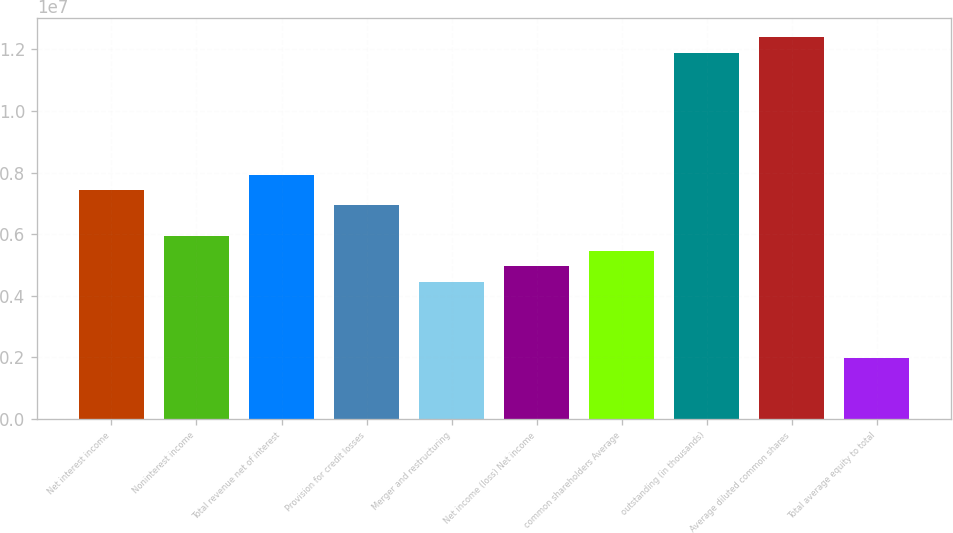Convert chart to OTSL. <chart><loc_0><loc_0><loc_500><loc_500><bar_chart><fcel>Net interest income<fcel>Noninterest income<fcel>Total revenue net of interest<fcel>Provision for credit losses<fcel>Merger and restructuring<fcel>Net income (loss) Net income<fcel>common shareholders Average<fcel>outstanding (in thousands)<fcel>Average diluted common shares<fcel>Total average equity to total<nl><fcel>7.43557e+06<fcel>5.94846e+06<fcel>7.93128e+06<fcel>6.93987e+06<fcel>4.46134e+06<fcel>4.95705e+06<fcel>5.45275e+06<fcel>1.18969e+07<fcel>1.23926e+07<fcel>1.98282e+06<nl></chart> 